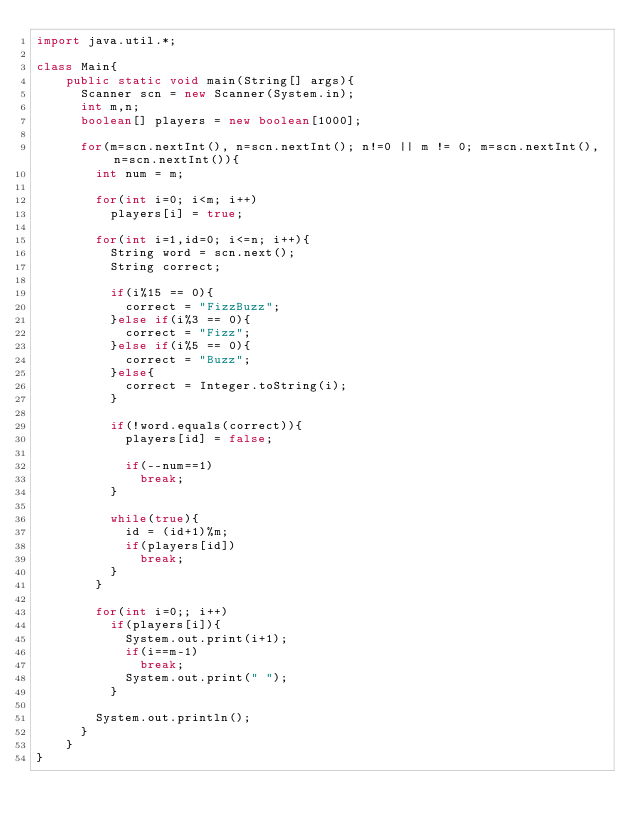Convert code to text. <code><loc_0><loc_0><loc_500><loc_500><_Java_>import java.util.*;

class Main{
    public static void main(String[] args){
    	Scanner scn = new Scanner(System.in);
    	int m,n;
    	boolean[] players = new boolean[1000];
    	
    	for(m=scn.nextInt(), n=scn.nextInt(); n!=0 || m != 0; m=scn.nextInt(), n=scn.nextInt()){
    		int num = m;
    		
    		for(int i=0; i<m; i++)
    			players[i] = true;
    		
    		for(int i=1,id=0; i<=n; i++){
    			String word = scn.next();
    			String correct;
    			
    			if(i%15 == 0){
    				correct = "FizzBuzz";
    			}else if(i%3 == 0){
    				correct = "Fizz";
    			}else if(i%5 == 0){
    				correct = "Buzz";
    			}else{
    				correct = Integer.toString(i);
    			}
    			
    			if(!word.equals(correct)){
    				players[id] = false;
    				
    				if(--num==1)
    					break;	
    			}
    			
    			while(true){
    				id = (id+1)%m;
    				if(players[id])
    					break;
    			}
    		}
    		
    		for(int i=0;; i++)
    			if(players[i]){
    				System.out.print(i+1);
    				if(i==m-1)
    					break;
    				System.out.print(" ");
    			}
    		
    		System.out.println();
    	}
    }
}</code> 